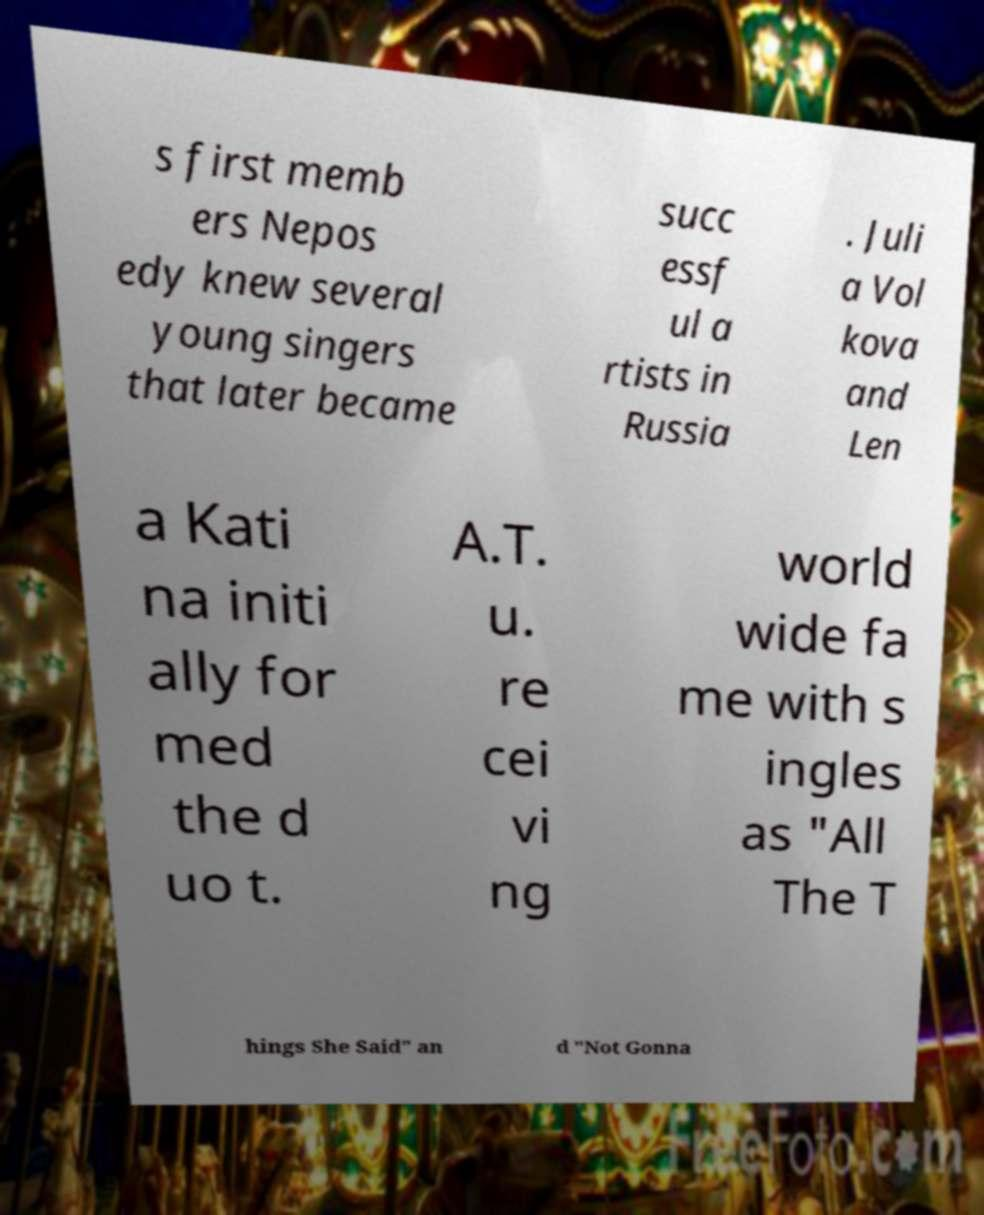Can you accurately transcribe the text from the provided image for me? s first memb ers Nepos edy knew several young singers that later became succ essf ul a rtists in Russia . Juli a Vol kova and Len a Kati na initi ally for med the d uo t. A.T. u. re cei vi ng world wide fa me with s ingles as "All The T hings She Said" an d "Not Gonna 